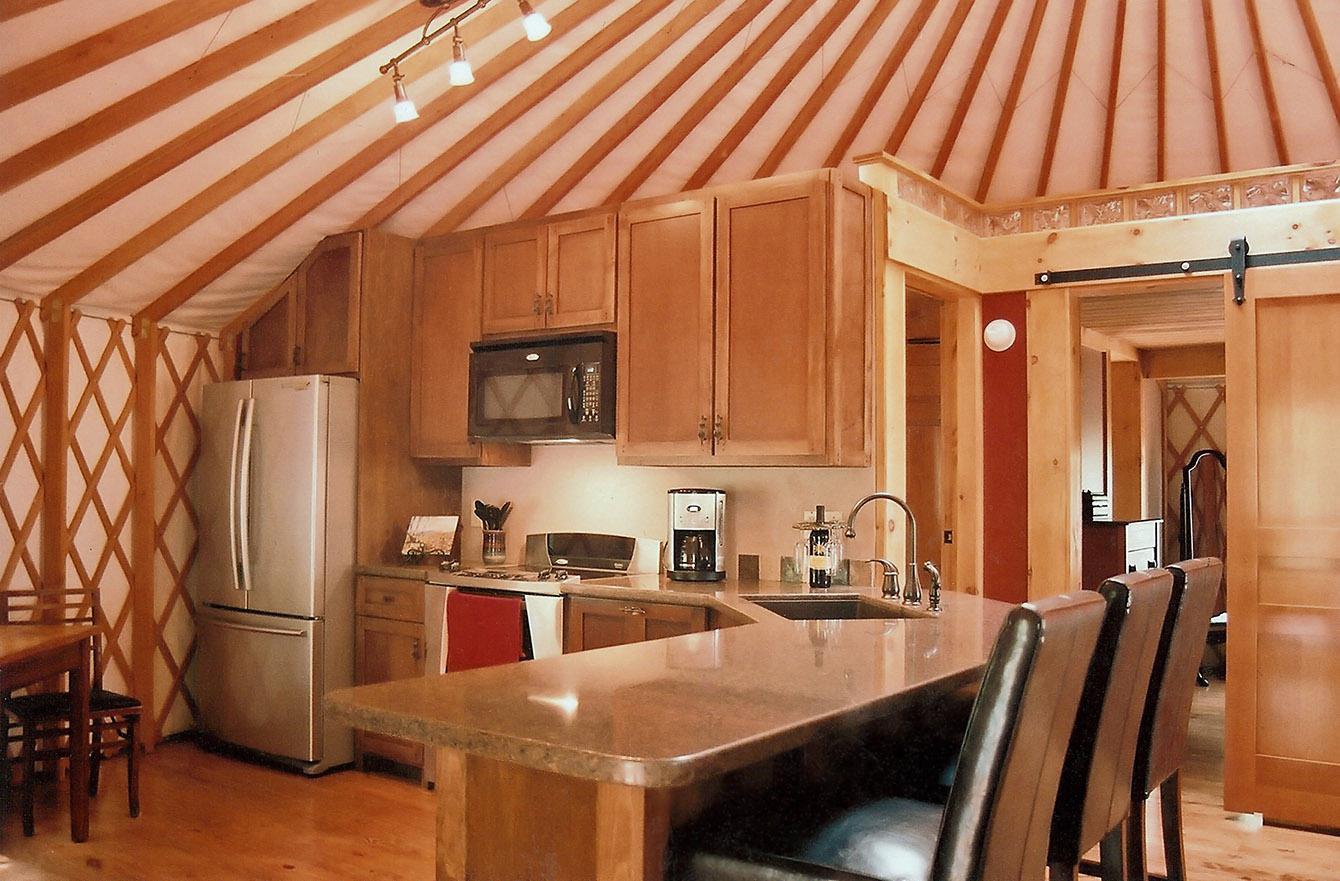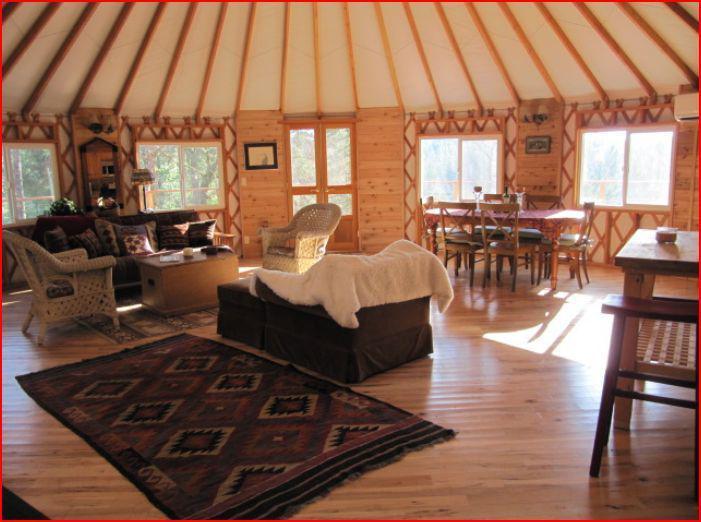The first image is the image on the left, the second image is the image on the right. Assess this claim about the two images: "There are at least three chairs around a table located near the windows in one of the images.". Correct or not? Answer yes or no. Yes. The first image is the image on the left, the second image is the image on the right. Evaluate the accuracy of this statement regarding the images: "One of the images has a ceiling fixture with at least three lights and the other image has no ceiling lights.". Is it true? Answer yes or no. Yes. 